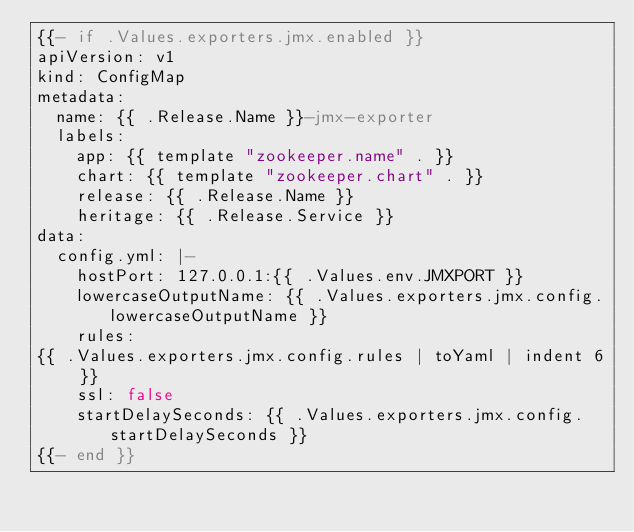Convert code to text. <code><loc_0><loc_0><loc_500><loc_500><_YAML_>{{- if .Values.exporters.jmx.enabled }}
apiVersion: v1
kind: ConfigMap
metadata:
  name: {{ .Release.Name }}-jmx-exporter
  labels:
    app: {{ template "zookeeper.name" . }}
    chart: {{ template "zookeeper.chart" . }}
    release: {{ .Release.Name }}
    heritage: {{ .Release.Service }}
data:
  config.yml: |-
    hostPort: 127.0.0.1:{{ .Values.env.JMXPORT }}
    lowercaseOutputName: {{ .Values.exporters.jmx.config.lowercaseOutputName }}
    rules:
{{ .Values.exporters.jmx.config.rules | toYaml | indent 6 }}
    ssl: false
    startDelaySeconds: {{ .Values.exporters.jmx.config.startDelaySeconds }}
{{- end }}
</code> 